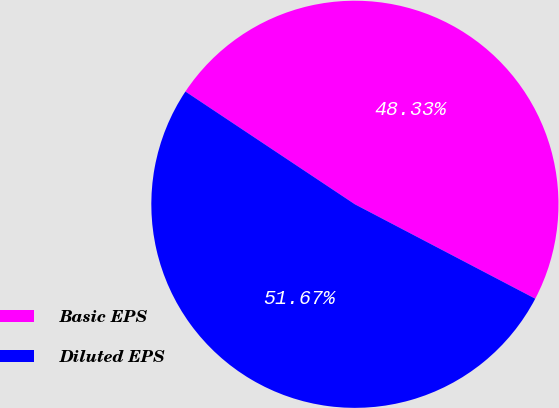<chart> <loc_0><loc_0><loc_500><loc_500><pie_chart><fcel>Basic EPS<fcel>Diluted EPS<nl><fcel>48.33%<fcel>51.67%<nl></chart> 